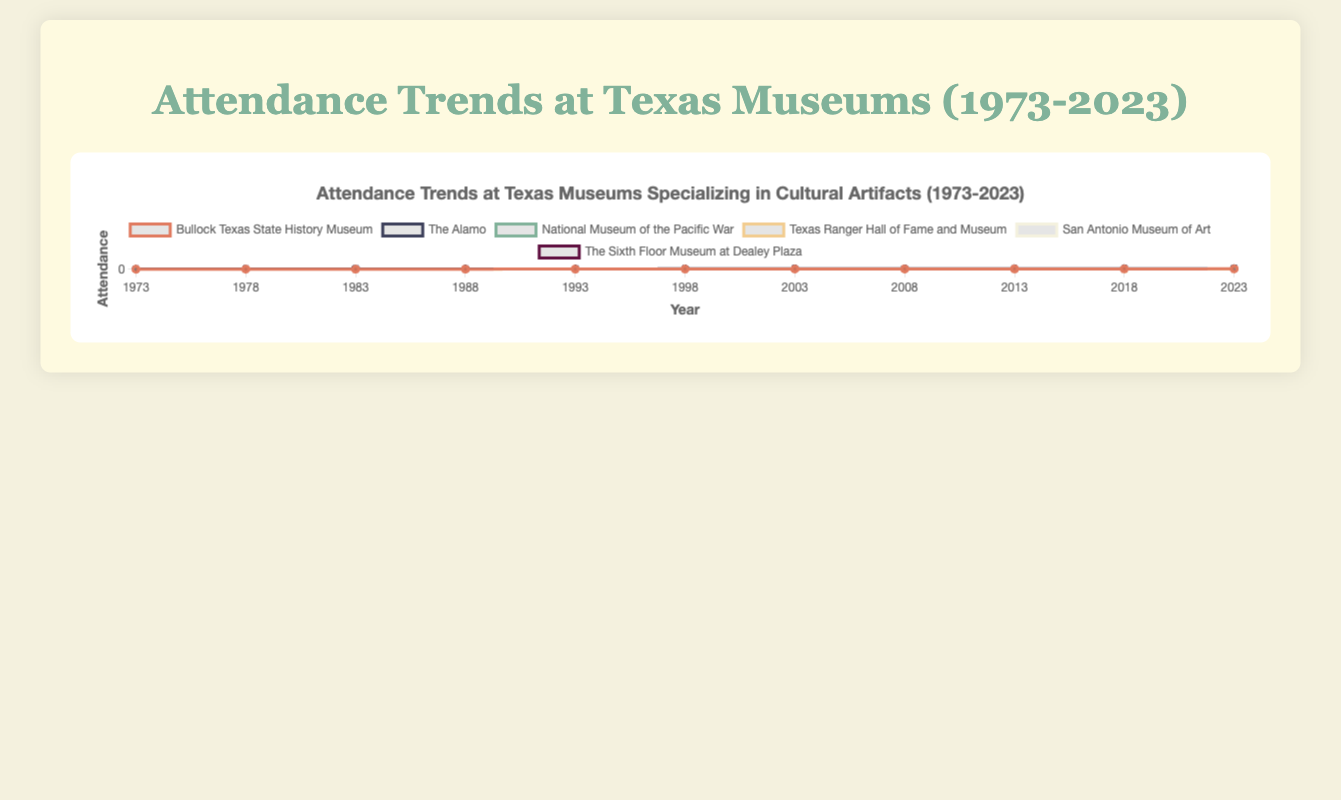Which museum had the highest attendance in 2023? To determine which museum had the highest attendance in 2023, we look for the highest endpoint on the line plot for the year 2023. The Alamo has the highest attendance.
Answer: The Alamo What is the difference in attendance between The Alamo and the Bullock Texas State History Museum in 2023? First, get the attendance numbers for The Alamo (107,854) and the Bullock Texas State History Museum (72,154) in 2023. Then, subtract the attendance of the Bullock Texas State History Museum from that of The Alamo: 107,854 - 72,154.
Answer: 35,700 How has the attendance at the Texas Ranger Hall of Fame and Museum changed from 1973 to 2023? To find the change, subtract the attendance in 1973 (18,452) from the attendance in 2023 (57,342) for the Texas Ranger Hall of Fame and Museum. The change is 57,342 - 18,452.
Answer: 38,890 Which museums saw a consistent increase in attendance over the past 50 years? To determine this, observe the trend lines for each museum. The attendance for the Bullock Texas State History Museum, The Alamo, National Museum of the Pacific War, Texas Ranger Hall of Fame and Museum, San Antonio Museum of Art, and The Sixth Floor Museum at Dealey Plaza all show an upward trend. Since all museums show a consistent increase, we list them all.
Answer: All museums What is the average attendance of The Sixth Floor Museum at Dealey Plaza over the 50-year period? First, add up the attendance numbers for The Sixth Floor Museum at Dealey Plaza over each year: 26,754 + 30,542 + 34,756 + 39,123 + 43,754 + 48,567 + 54,012 + 60,234 + 67,123 + 74,352 + 81,765. Then, divide the total by the number of years (11).
Answer: 49,178.64 Which museum has the steepest increase in attendance between any two consecutive time periods? To find the steepest increase, compare the differences in attendance between consecutive years for all museums. Identify the largest difference. The Alamo saw a particularly large increase from 2018 to 2023 (107,854 - 100,123 = 7,731). After comparing all consecutive periods, we can see that The Alamo from 2018 to 2023 has the largest increase.
Answer: The Alamo Which museum had the lowest attendance in 1973? Look at the starting points of all the lines in 1973. The Bullock Texas State History Museum had the lowest attendance in 1973.
Answer: Bullock Texas State History Museum By how much did the attendance at the San Antonio Museum of Art increase between 1998 and 2013? First, find the attendance at the San Antonio Museum of Art in 1998 (46,578) and in 2013 (65,521). Subtract the 1998 attendance from the 2013 attendance: 65,521 - 46,578.
Answer: 18,943 Which museum's attendance crosses 50,000 first in the timeline provided? Look at the lines and identify the first museum to reach an attendance point of 50,000. The Alamo crosses the 50,000 mark around 1978.
Answer: The Alamo 